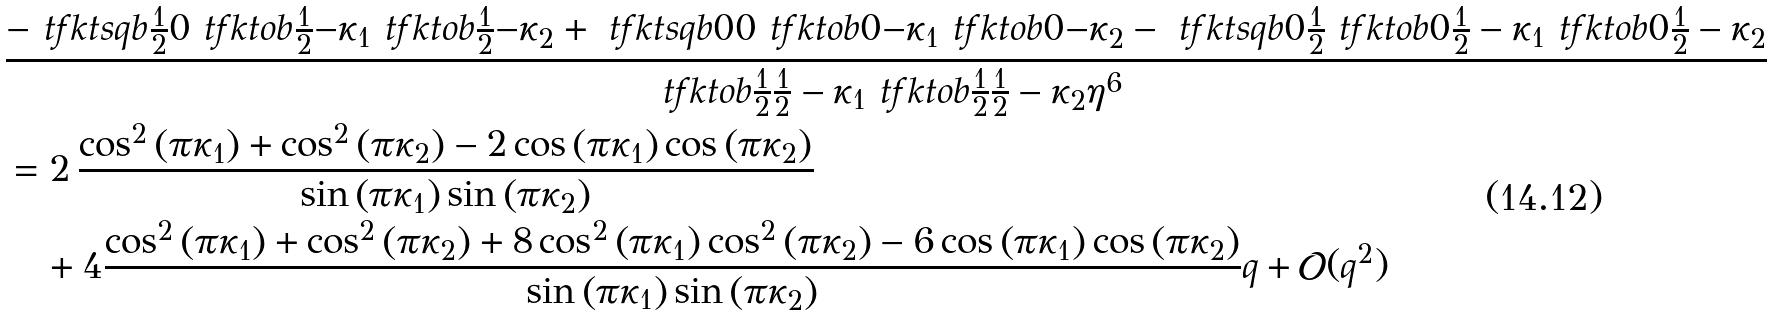Convert formula to latex. <formula><loc_0><loc_0><loc_500><loc_500>& \frac { - \ t f k t s q b { \frac { 1 } { 2 } } { 0 } \ t f k t o b { \frac { 1 } { 2 } } { - \kappa _ { 1 } } \ t f k t o b { \frac { 1 } { 2 } } { - \kappa _ { 2 } } + \ t f k t s q b { 0 } { 0 } \ t f k t o b { 0 } { - \kappa _ { 1 } } \ t f k t o b { 0 } { - \kappa _ { 2 } } - \ t f k t s q b { 0 } { \frac { 1 } { 2 } } \ t f k t o b { 0 } { \frac { 1 } { 2 } - \kappa _ { 1 } } \ t f k t o b { 0 } { \frac { 1 } { 2 } - \kappa _ { 2 } } } { \ t f k t o b { \frac { 1 } { 2 } } { \frac { 1 } { 2 } - \kappa _ { 1 } } \ t f k t o b { \frac { 1 } { 2 } } { \frac { 1 } { 2 } - \kappa _ { 2 } } \eta ^ { 6 } } \\ & = 2 \, { \frac { \cos ^ { 2 } \left ( \pi { \kappa _ { 1 } } \right ) + \cos ^ { 2 } \left ( \pi { \kappa _ { 2 } } \right ) - 2 \cos \left ( \pi { \kappa _ { 1 } } \right ) \cos \left ( \pi { \kappa _ { 2 } } \right ) } { \sin \left ( \pi { \kappa _ { 1 } } \right ) \sin \left ( \pi { \kappa _ { 2 } } \right ) } } \\ & \quad + 4 { \frac { \cos ^ { 2 } \left ( \pi { \kappa _ { 1 } } \right ) + \cos ^ { 2 } \left ( \pi { \kappa _ { 2 } } \right ) + 8 \cos ^ { 2 } \left ( \pi { \kappa _ { 1 } } \right ) \cos ^ { 2 } \left ( \pi { \kappa _ { 2 } } \right ) - 6 \cos \left ( \pi { \kappa _ { 1 } } \right ) \cos \left ( \pi { \kappa _ { 2 } } \right ) } { \sin \left ( \pi { \kappa _ { 1 } } \right ) \sin \left ( \pi { \kappa _ { 2 } } \right ) } } q + \mathcal { O } ( q ^ { 2 } )</formula> 